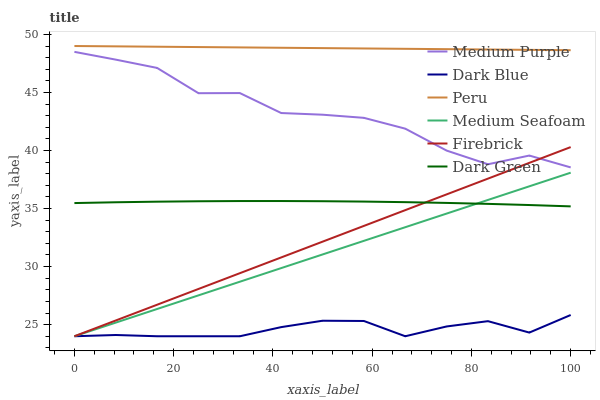Does Dark Blue have the minimum area under the curve?
Answer yes or no. Yes. Does Peru have the maximum area under the curve?
Answer yes or no. Yes. Does Medium Purple have the minimum area under the curve?
Answer yes or no. No. Does Medium Purple have the maximum area under the curve?
Answer yes or no. No. Is Peru the smoothest?
Answer yes or no. Yes. Is Medium Purple the roughest?
Answer yes or no. Yes. Is Dark Blue the smoothest?
Answer yes or no. No. Is Dark Blue the roughest?
Answer yes or no. No. Does Firebrick have the lowest value?
Answer yes or no. Yes. Does Medium Purple have the lowest value?
Answer yes or no. No. Does Peru have the highest value?
Answer yes or no. Yes. Does Medium Purple have the highest value?
Answer yes or no. No. Is Firebrick less than Peru?
Answer yes or no. Yes. Is Medium Purple greater than Dark Green?
Answer yes or no. Yes. Does Medium Purple intersect Firebrick?
Answer yes or no. Yes. Is Medium Purple less than Firebrick?
Answer yes or no. No. Is Medium Purple greater than Firebrick?
Answer yes or no. No. Does Firebrick intersect Peru?
Answer yes or no. No. 